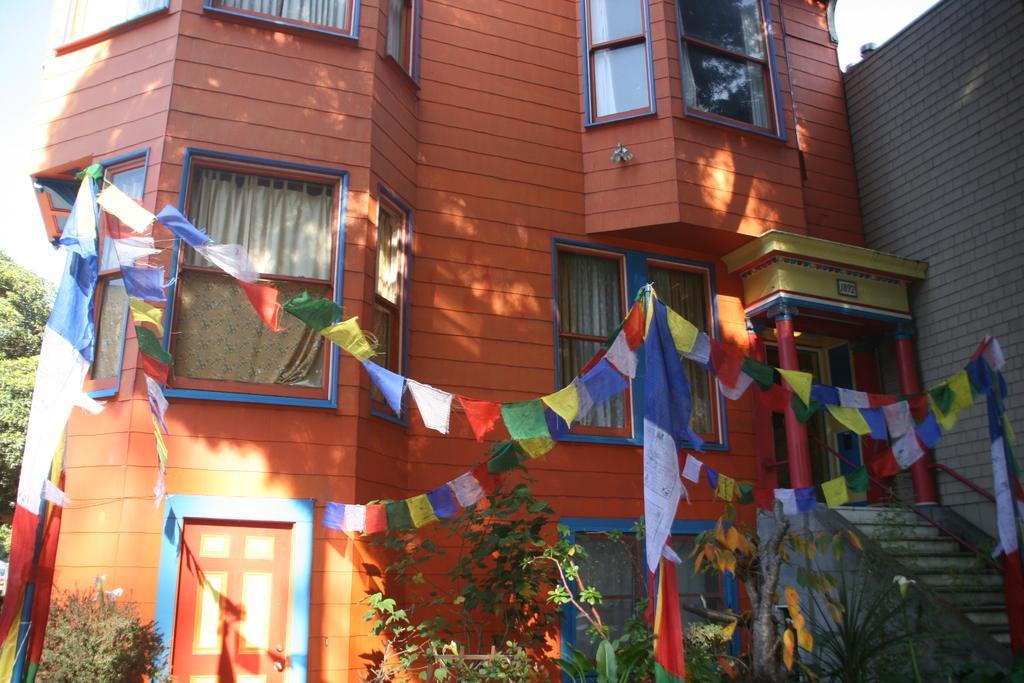How would you summarize this image in a sentence or two? In the foreground of this picture, there are few flags and few bunting flags to it. In the background, we can see a building, stairs, door, plants, trees and the sky. 